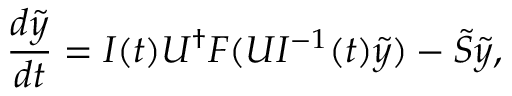<formula> <loc_0><loc_0><loc_500><loc_500>\frac { d \tilde { y } } { d t } = I ( t ) U ^ { \dagger } F ( U I ^ { - 1 } ( t ) \tilde { y } ) - \tilde { S } \tilde { y } ,</formula> 